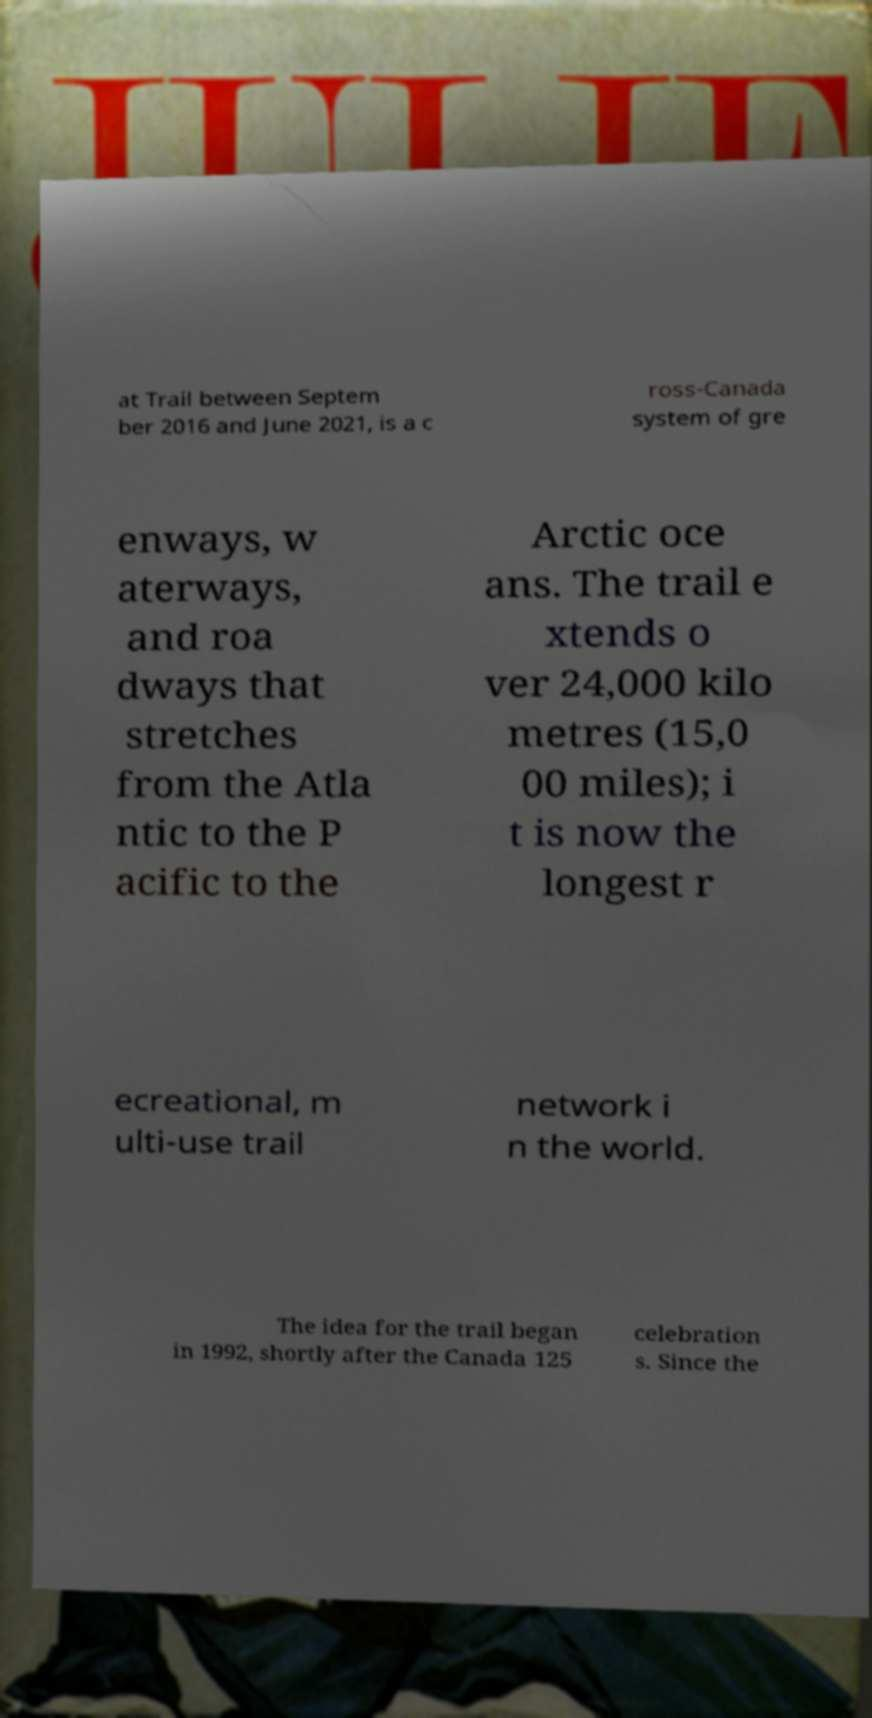Please identify and transcribe the text found in this image. at Trail between Septem ber 2016 and June 2021, is a c ross-Canada system of gre enways, w aterways, and roa dways that stretches from the Atla ntic to the P acific to the Arctic oce ans. The trail e xtends o ver 24,000 kilo metres (15,0 00 miles); i t is now the longest r ecreational, m ulti-use trail network i n the world. The idea for the trail began in 1992, shortly after the Canada 125 celebration s. Since the 